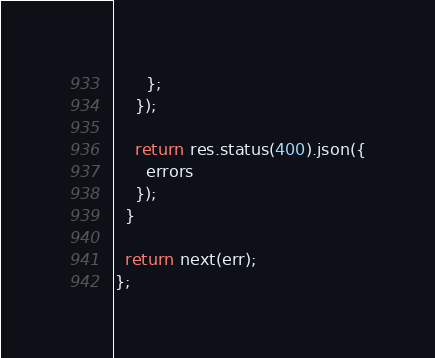Convert code to text. <code><loc_0><loc_0><loc_500><loc_500><_JavaScript_>      };
    });

    return res.status(400).json({
      errors
    });
  }

  return next(err);
};
</code> 